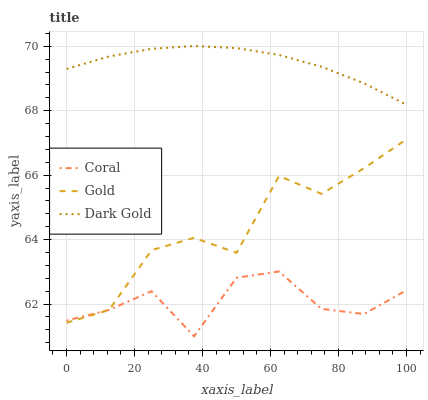Does Coral have the minimum area under the curve?
Answer yes or no. Yes. Does Dark Gold have the maximum area under the curve?
Answer yes or no. Yes. Does Gold have the minimum area under the curve?
Answer yes or no. No. Does Gold have the maximum area under the curve?
Answer yes or no. No. Is Dark Gold the smoothest?
Answer yes or no. Yes. Is Gold the roughest?
Answer yes or no. Yes. Is Gold the smoothest?
Answer yes or no. No. Is Dark Gold the roughest?
Answer yes or no. No. Does Coral have the lowest value?
Answer yes or no. Yes. Does Gold have the lowest value?
Answer yes or no. No. Does Dark Gold have the highest value?
Answer yes or no. Yes. Does Gold have the highest value?
Answer yes or no. No. Is Coral less than Dark Gold?
Answer yes or no. Yes. Is Dark Gold greater than Coral?
Answer yes or no. Yes. Does Gold intersect Coral?
Answer yes or no. Yes. Is Gold less than Coral?
Answer yes or no. No. Is Gold greater than Coral?
Answer yes or no. No. Does Coral intersect Dark Gold?
Answer yes or no. No. 